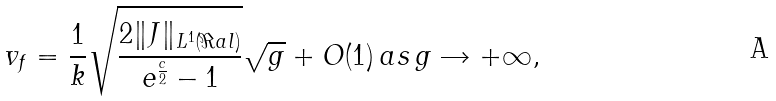<formula> <loc_0><loc_0><loc_500><loc_500>v _ { f } = \frac { 1 } { k } \sqrt { \frac { 2 \| J \| _ { L ^ { 1 } ( \Re a l ) } } { e ^ { \frac { c } { 2 } } - 1 } } \sqrt { g } + O ( 1 ) \, a s \, g \rightarrow + \infty ,</formula> 